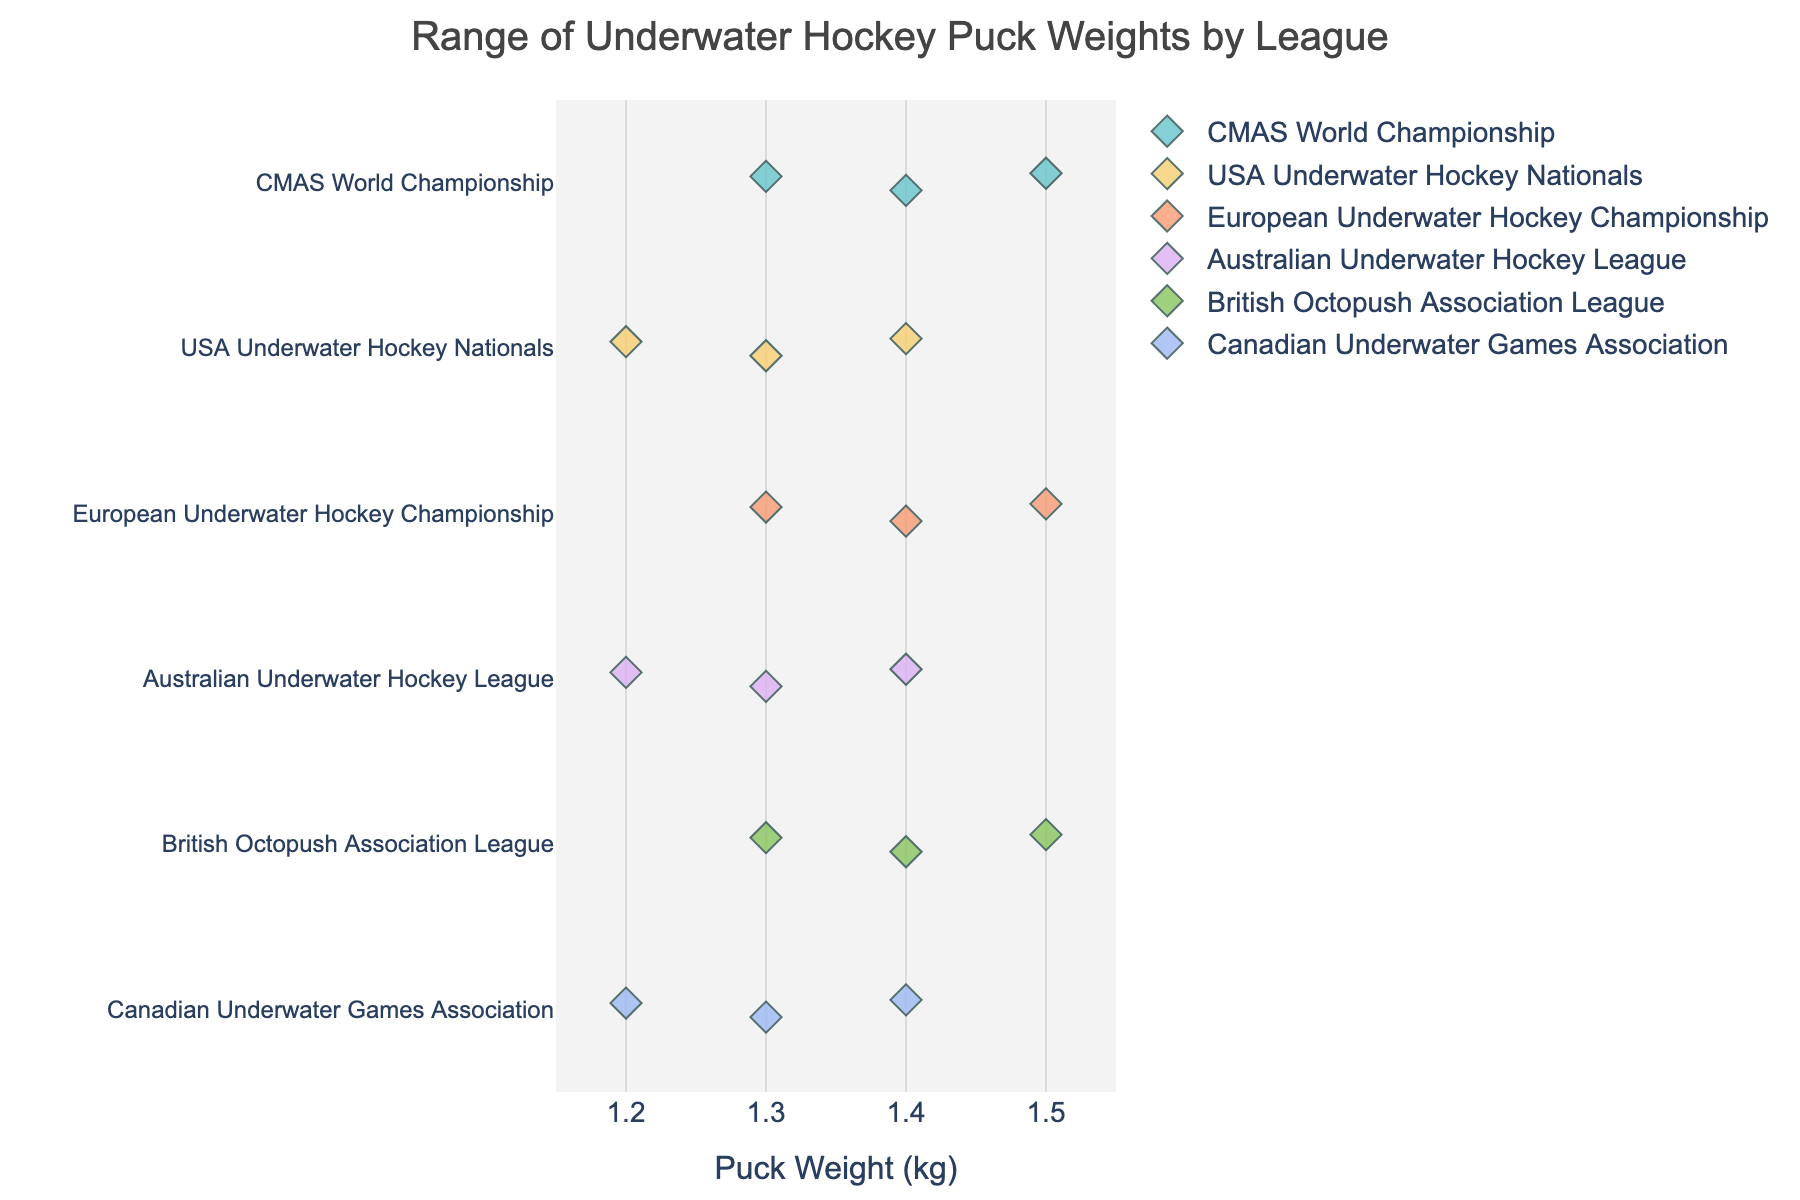What is the title of the figure? The title of the figure is usually at the top and explicitly states what the figure is about. In this case, the title of the figure reads "Range of Underwater Hockey Puck Weights by League."
Answer: Range of Underwater Hockey Puck Weights by League What is the weight range of pucks used in the USA Underwater Hockey Nationals? To find the weight range, look at the spread of data points associated with the "USA Underwater Hockey Nationals" on the y-axis. The weights range from 1.2 kg to 1.4 kg.
Answer: 1.2 kg to 1.4 kg How many different leagues are shown in the plot? Count the number of unique names on the y-axis (left side) corresponding to different leagues. There are six different leagues listed.
Answer: Six What is the median puck weight used in the CMAS World Championship? For the CMAS World Championship's puck weights (1.3 kg, 1.4 kg, and 1.5 kg), the median value is the middle value. Essentially, the second value in the sorted list (1.3, 1.4, 1.5) is 1.4 kg.
Answer: 1.4 kg Which league uses the widest range of puck weights? By observing the horizontal spread of the data points for each league, the Australian Underwater Hockey League uses the widest range (from 1.2 kg to 1.4 kg), along with several other leagues like the USA Underwater Hockey Nationals and Canadian Underwater Games Association. All these leagues span from 1.2 kg to 1.4 kg.
Answer: Australian Underwater Hockey League, USA Underwater Hockey Nationals, Canadian Underwater Games Association Are there any leagues using a puck weight of 1.5 kg? Look for data points aligned vertically with the 1.5 kg tick on the x-axis. The leagues using 1.5 kg are CMAS World Championship, European Underwater Hockey Championship, and British Octopush Association League.
Answer: CMAS World Championship, European Underwater Hockey Championship, British Octopush Association League What is the average puck weight for the British Octopush Association League? The puck weights for the British Octopush Association League are 1.3 kg, 1.4 kg, and 1.5 kg. The average is calculated as (1.3 + 1.4 + 1.5)/3 = 4.2/3 = 1.4 kg.
Answer: 1.4 kg Which league exclusively uses puck weights of 1.3 kg and above? By checking each league's range, we can see that the British Octopush Association League has pucks starting from 1.3 kg up to 1.5 kg, indicating this league exclusively uses puck weights of 1.3 kg and above.
Answer: British Octopush Association League What is the smallest puck weight used among all leagues? The smallest puck weight is identified by finding the minimum value among all data points. The puck weight of 1.2 kg is the smallest and used by leagues like USA Underwater Hockey Nationals, Australian Underwater Hockey League, and Canadian Underwater Games Association.
Answer: 1.2 kg Which two leagues have exactly the same range of puck weights? By comparing the weight ranges of each league, we can see that the CMAS World Championship and the European Underwater Hockey Championship both use puck weights ranging from 1.3 kg to 1.5 kg.
Answer: CMAS World Championship and European Underwater Hockey Championship 